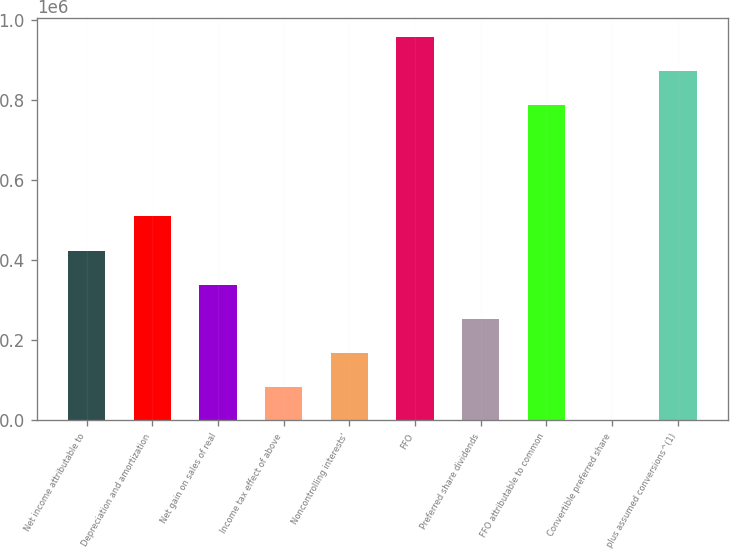<chart> <loc_0><loc_0><loc_500><loc_500><bar_chart><fcel>Net income attributable to<fcel>Depreciation and amortization<fcel>Net gain on sales of real<fcel>Income tax effect of above<fcel>Noncontrolling interests'<fcel>FFO<fcel>Preferred share dividends<fcel>FFO attributable to common<fcel>Convertible preferred share<fcel>plus assumed conversions^(1)<nl><fcel>422447<fcel>509367<fcel>337995<fcel>84640.6<fcel>169092<fcel>956517<fcel>253544<fcel>787614<fcel>189<fcel>872066<nl></chart> 